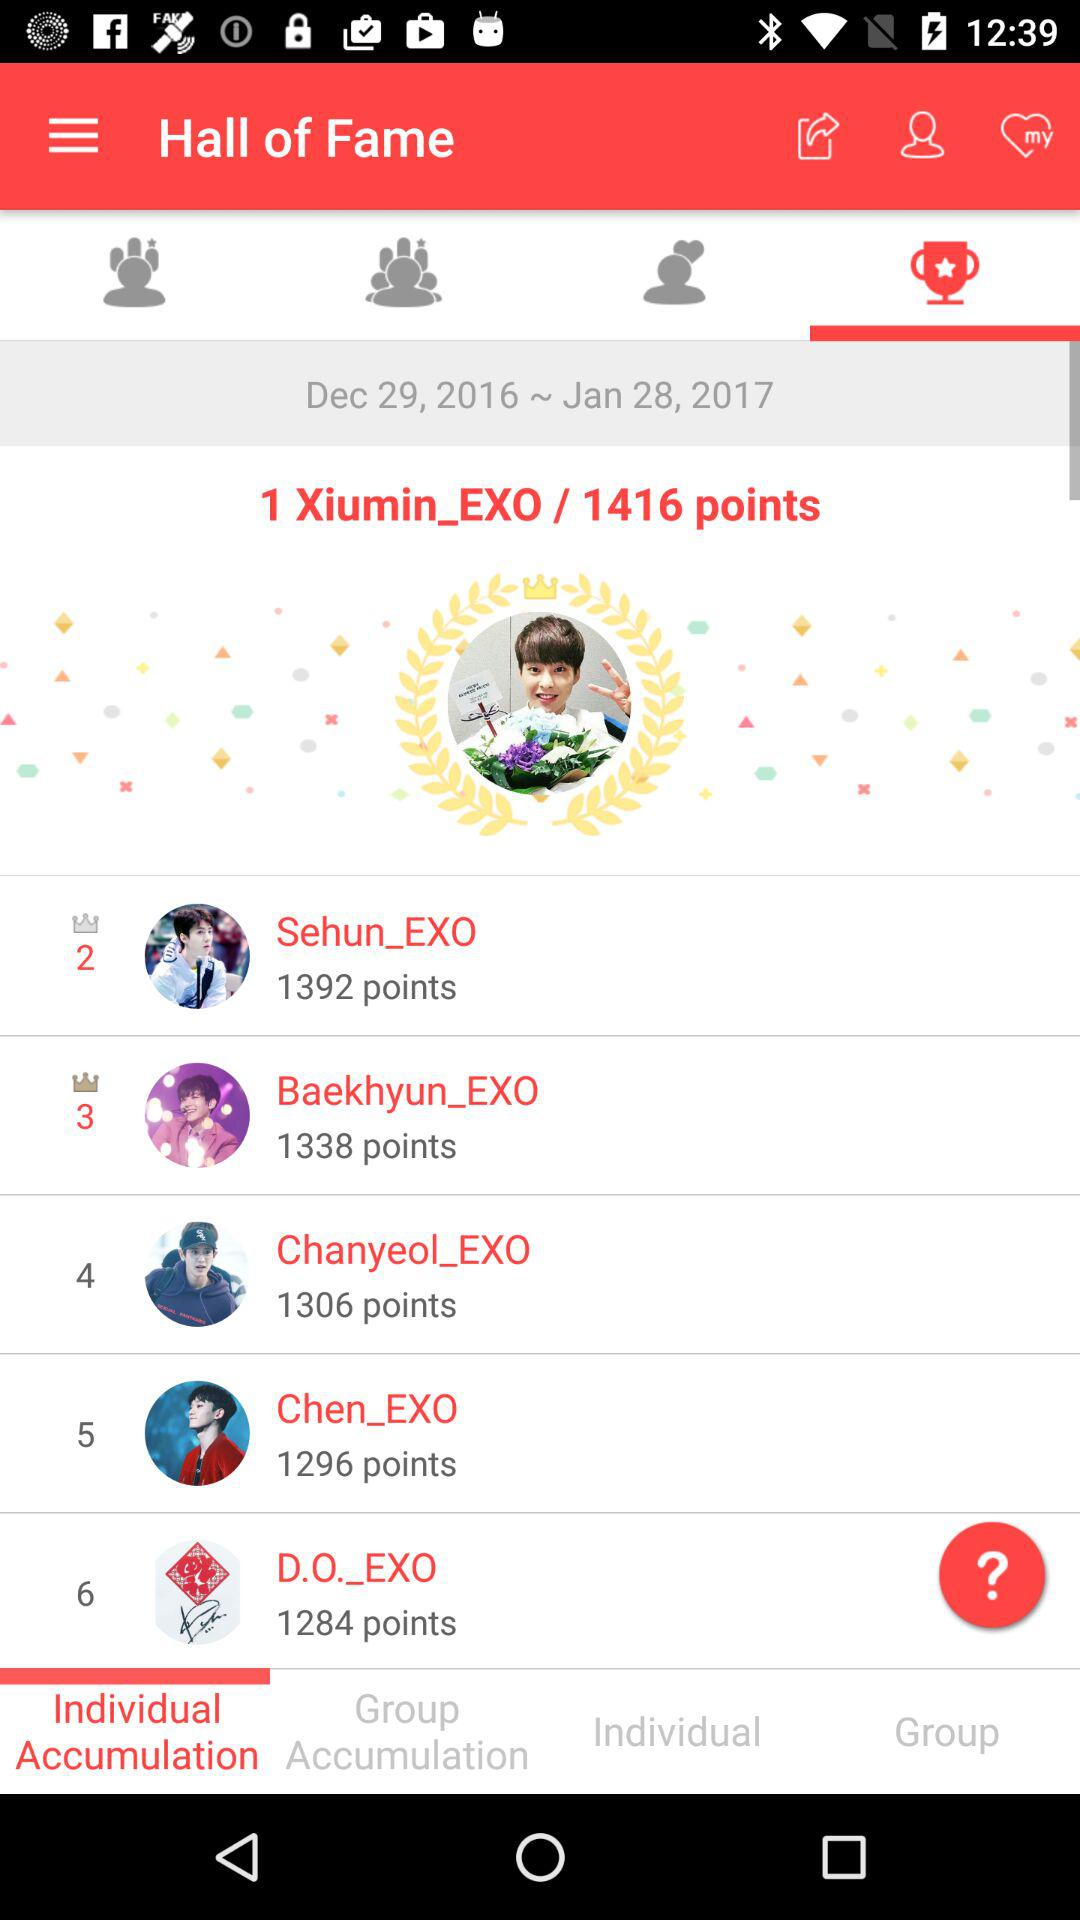How many points has "Chanyeol_EXO" scored? "Chanyeol_EXO" has scored 1306 points. 